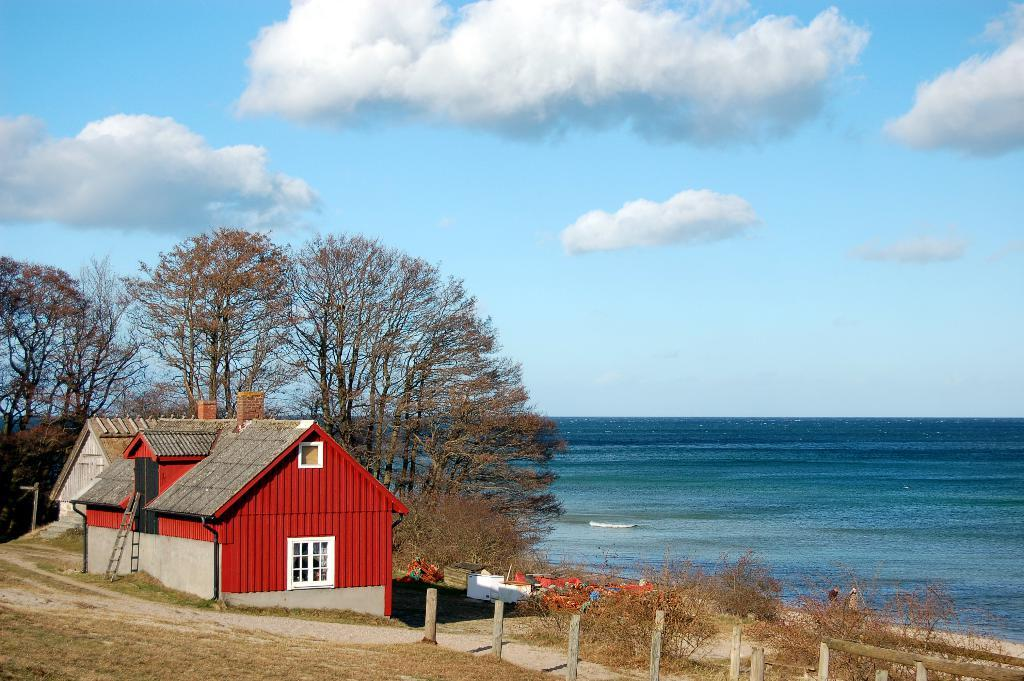What type of structures can be seen in the image? There are houses in the image. What type of vegetation is present in the image? There are trees in the image. What natural element is visible in the background of the image? There is water visible in the background of the image. What can be seen in the sky in the image? There are clouds visible in the background of the image. What type of rose is growing in the image? There is no rose present in the image. How many dogs can be seen playing in the water in the image? There are no dogs present in the image. 